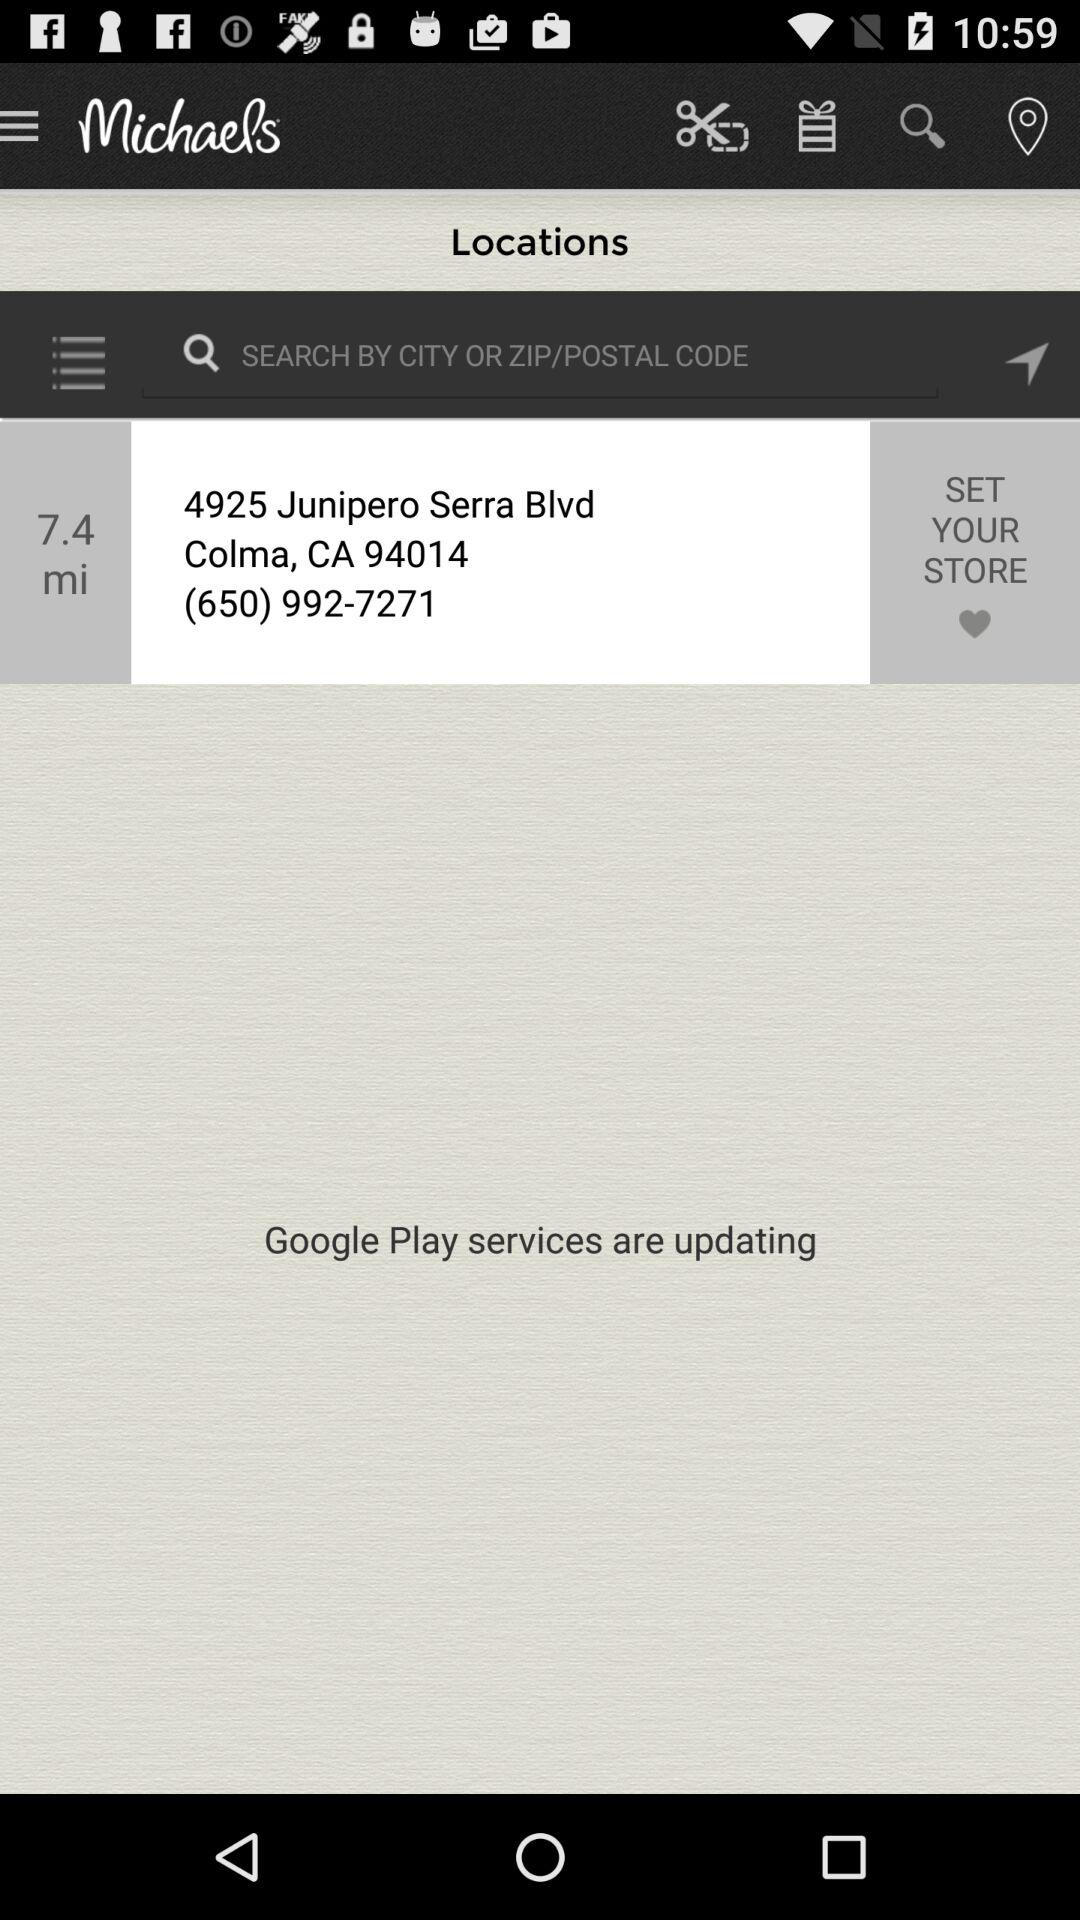By which code can we search locations? You can search locations by ZIP or postal code. 